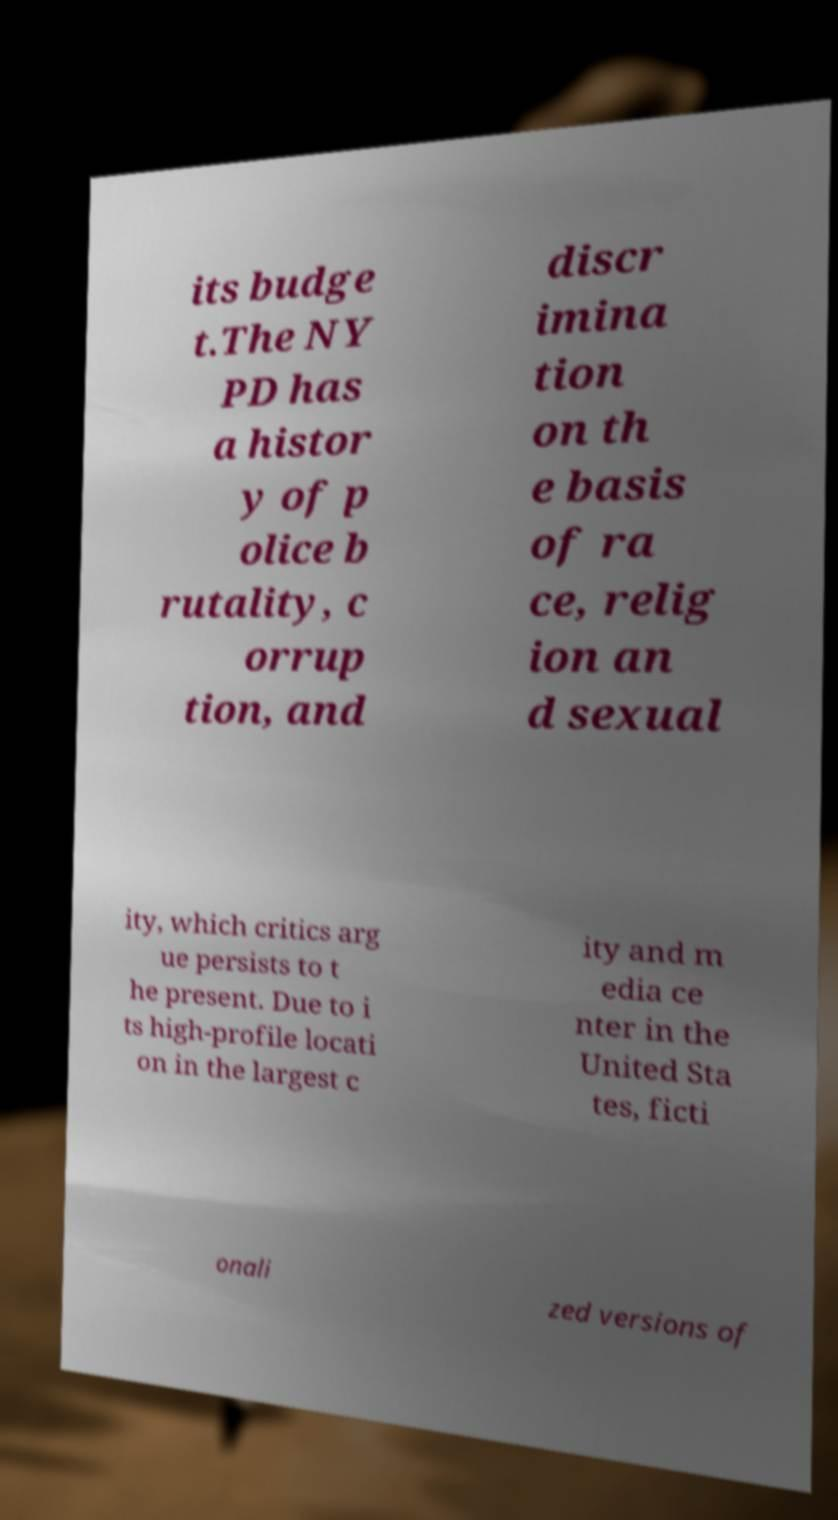Could you extract and type out the text from this image? its budge t.The NY PD has a histor y of p olice b rutality, c orrup tion, and discr imina tion on th e basis of ra ce, relig ion an d sexual ity, which critics arg ue persists to t he present. Due to i ts high-profile locati on in the largest c ity and m edia ce nter in the United Sta tes, ficti onali zed versions of 